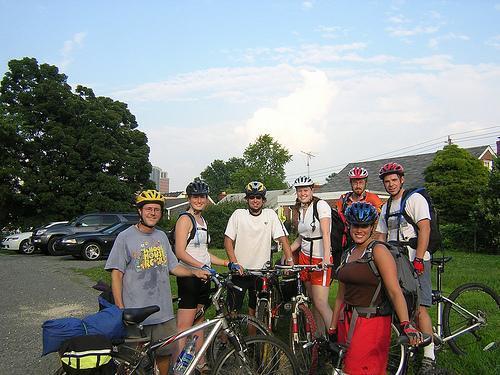How many people are there?
Give a very brief answer. 7. How many people are wearing sunglasses?
Give a very brief answer. 1. How many bicycle helmets are contain the color yellow?
Give a very brief answer. 2. 